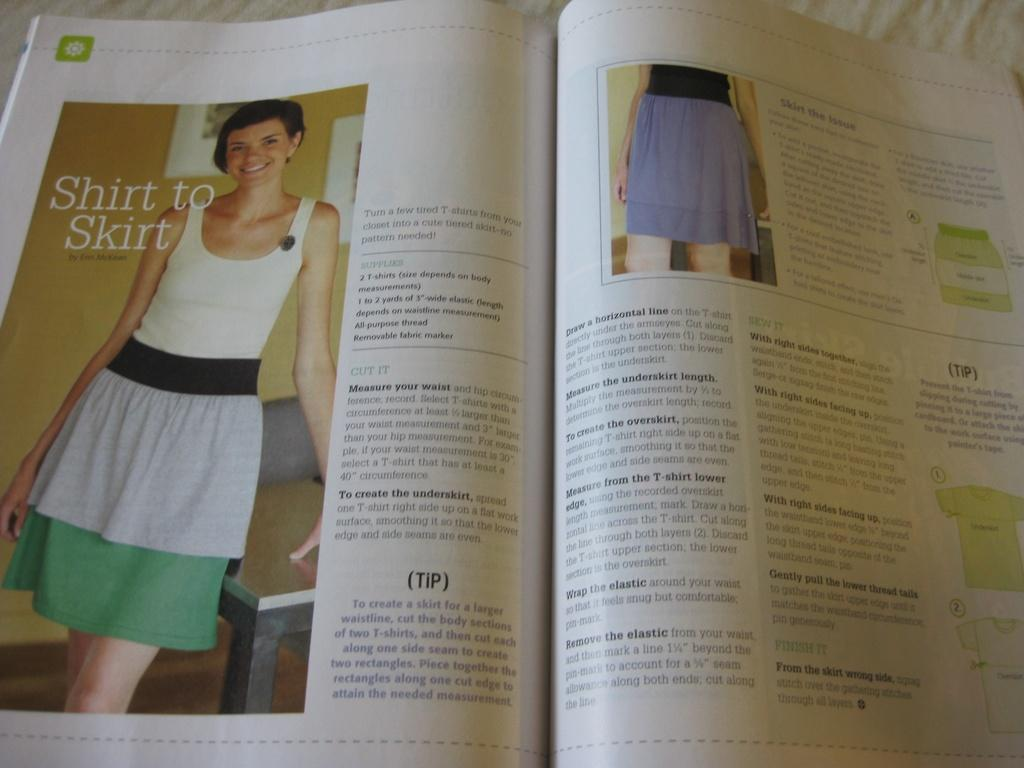Provide a one-sentence caption for the provided image. A magazine article entitled Shirt to Skirt shows a photo of a young woman. 